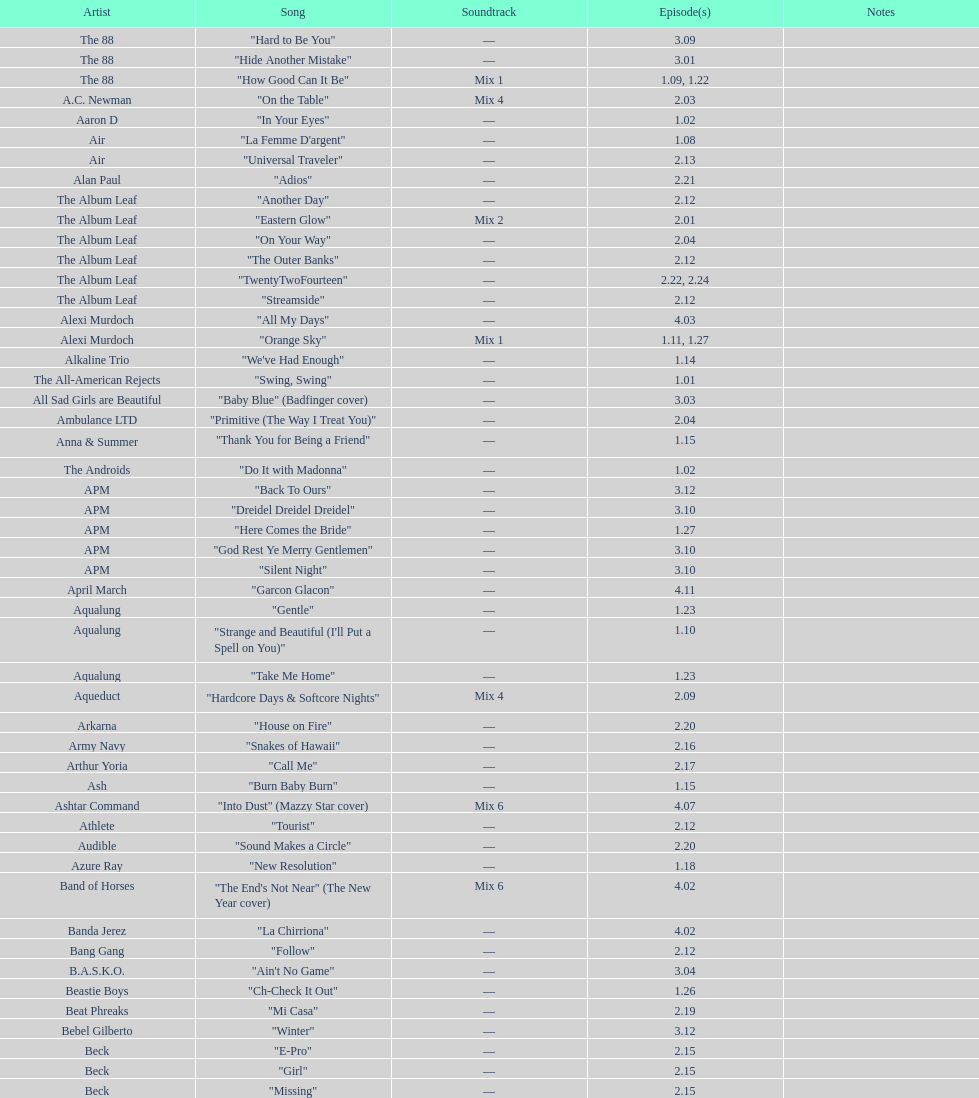Which musician performed "girl" and "el pro"? Beck. 